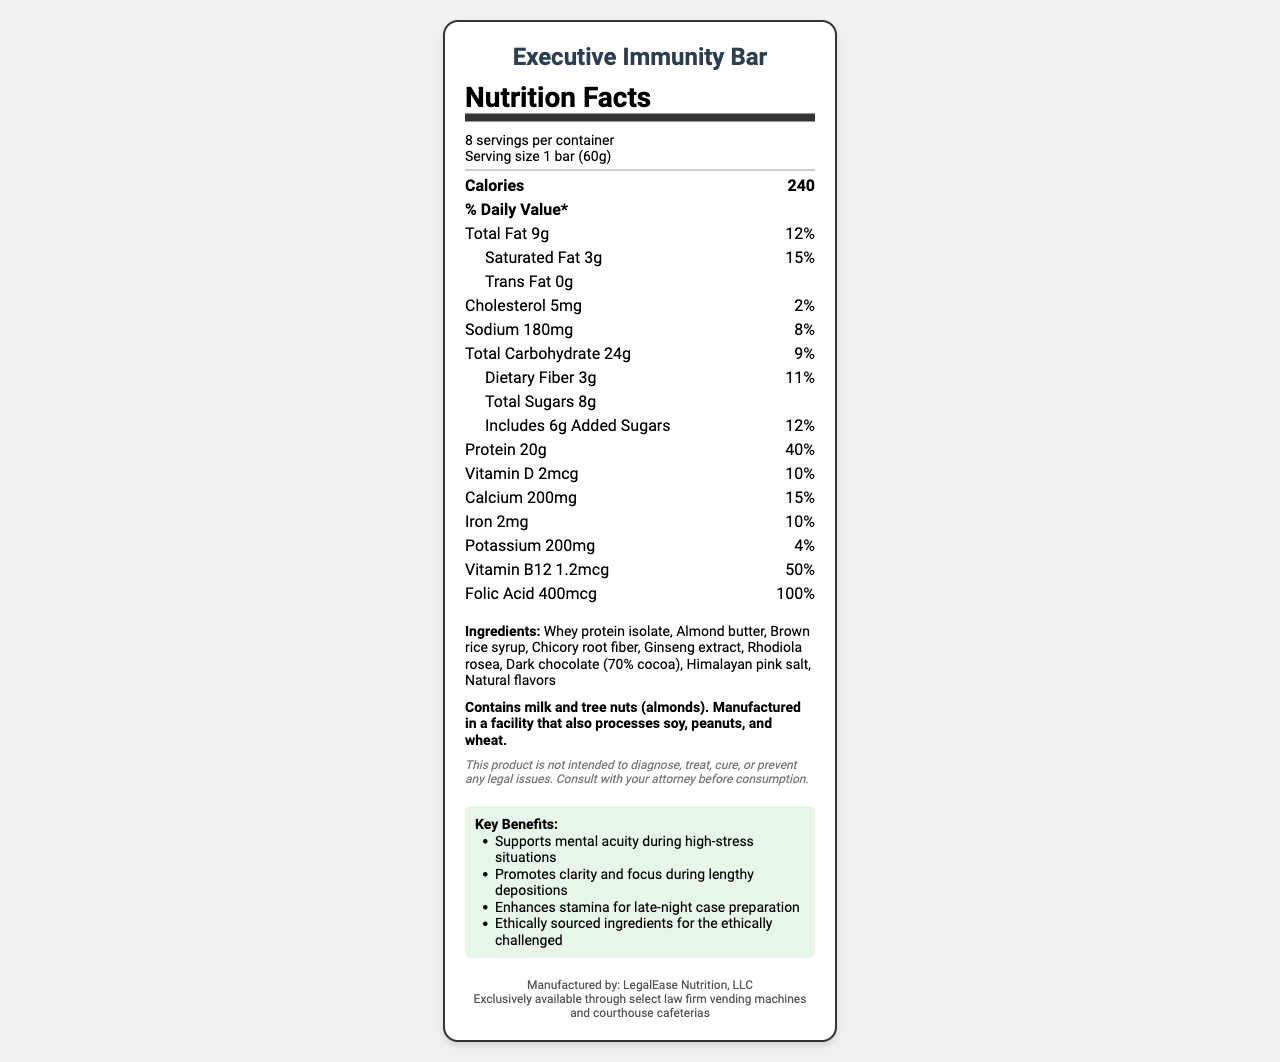what is the serving size of the Executive Immunity Bar? The serving size is explicitly stated as "1 bar (60g)".
Answer: 1 bar (60g) how many calories are in one serving? The calories per serving are clearly marked as 240.
Answer: 240 what is the total fat content and its daily value percentage? The total fat content is 9g, and its daily value percentage is 12%.
Answer: 9g, 12% does the Executive Immunity Bar contain any trans fat? The label shows "Trans Fat 0g", meaning there is no trans fat.
Answer: No how much protein does one bar provide? The protein content per serving is listed as 20g.
Answer: 20g what are the first three ingredients listed? The ingredients list starts with "Whey protein isolate, Almond butter, Brown rice syrup".
Answer: Whey protein isolate, Almond butter, Brown rice syrup what is the daily value percentage of vitamin B12? The vitamin B12 daily value percentage is indicated as 50%.
Answer: 50% what are the potential allergens mentioned? The allergen information states that the product contains milk and tree nuts (almonds).
Answer: Milk and tree nuts (almonds). what is one of the marketing claims made by this product? One of the marketing claims is "Supports mental acuity during high-stress situations".
Answer: Supports mental acuity during high-stress situations how many servings are in one container of this product? A. 4 B. 6 C. 8 D. 10 The document states there are 8 servings per container.
Answer: C. 8 what is the daily value percentage of folic acid per serving? A. 10% B. 25% C. 50% D. 100% The folic acid daily value percentage is mentioned as 100%.
Answer: D. 100% is this product's caloric content high or low? Whether the caloric content is considered high or low depends on individual dietary needs and guidelines. 240 calories can be moderate to high for some.
Answer: Depends summarize the entire document. The document details the nutritional and marketing details of a high-end protein bar aimed at executives, including its nutritional content, ingredient list, allergens, and special claims.
Answer: The Executive Immunity Bar is a high-end protein bar with 240 calories per serving, marketed towards white-collar executives under stress. It contains 20g of protein, 9g of fat, and 24g of carbohydrates, with various vitamins and minerals. The product highlights mental acuity and stamina enhancement and contains allergens like milk and tree nuts. It's manufactured by LegalEase Nutrition, LLC, and distributed in specific legal settings. what is the manufacturing company of this product? The manufacturer is explicitly stated as LegalEase Nutrition, LLC.
Answer: LegalEase Nutrition, LLC where can one purchase this bar? Distribution is specifically through select law firm vending machines and courthouse cafeterias.
Answer: Select law firm vending machines and courthouse cafeterias what type of chocolate is used in the Executive Immunity Bar? The ingredients list includes "Dark chocolate (70% cocoa)".
Answer: Dark chocolate (70% cocoa) how much sodium does one serving contain? The sodium content per serving is listed as 180mg.
Answer: 180mg what is the legal disclaimer provided on the document? The legal disclaimer is meant to clarify the product's nature and provides a humorous touch related to the target market.
Answer: This product is not intended to diagnose, treat, cure, or prevent any legal issues. Consult with your attorney before consumption. is the total sugar content explicitly broken down in the document? The document specifies "Total Sugars 8g" and "Includes 6g Added Sugars".
Answer: Yes who is the target market for the Executive Immunity Bar? The specific target market is not directly stated in the document, although the marketing claims suggest it is aimed at white-collar executives under stress.
Answer: Cannot be determined 